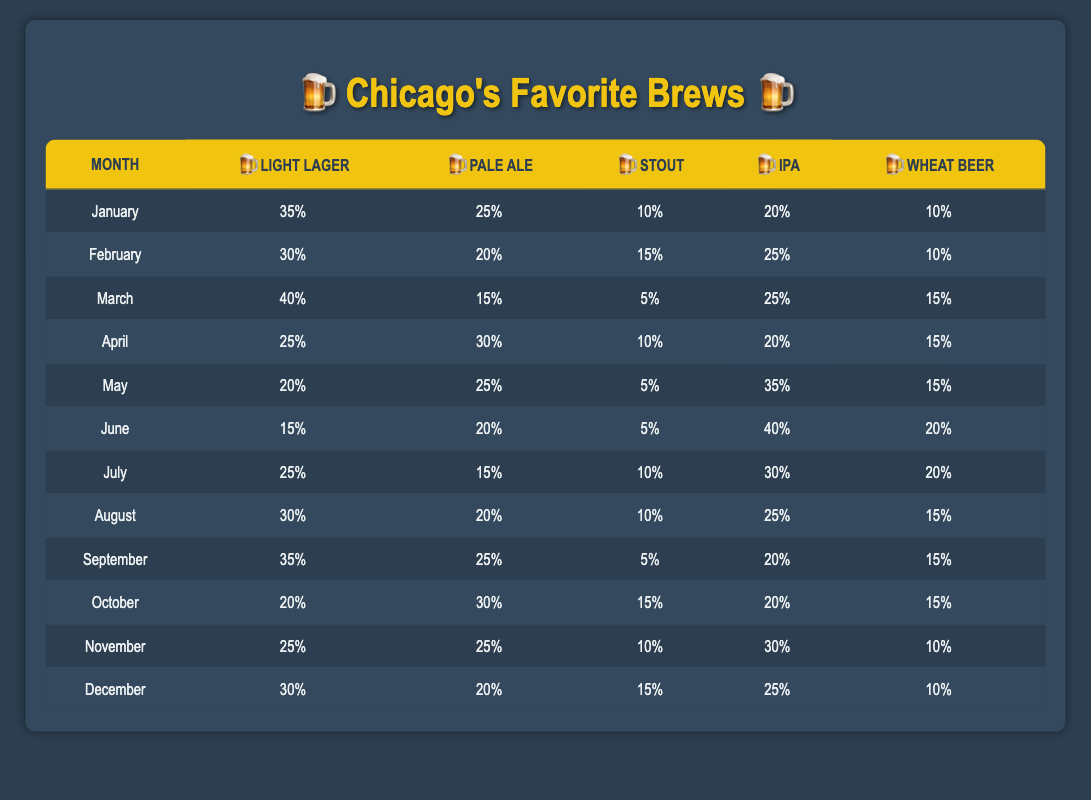What was the customer preference for Light Lager in December? In December, the percentage of customers who preferred Light Lager is listed in the table as 30%.
Answer: 30% Which beer type had the lowest percentage in March? In March, the Stout had the lowest percentage at 5%, compared to other types, which were higher.
Answer: 5% In which month did IPA reach its highest percentage and what was that percentage? Looking through the table, IPA reached its highest percentage in June at 40%.
Answer: 40% in June What is the total percentage preference for Pale Ale over the entire year? Summing the percentages for Pale Ale across all months: 25 + 20 + 15 + 30 + 25 + 20 + 15 + 20 + 25 + 30 + 25 + 20 = 300. The total percentage is 300%.
Answer: 300% Did customer preferences for Stout ever exceed 15%? By reviewing the table, Stout exceeded 15% in January (10%) and February (15%), but never went above that threshold in any month.
Answer: No What was the average percentage for Wheat Beer throughout the year? Wheat Beer percentages: 10, 10, 15, 15, 15, 20, 20, 15, 15, 15, 10, 10. The sum is 10 + 10 + 15 + 15 + 15 + 20 + 20 + 15 + 15 + 15 + 10 + 10 =  160. There are 12 values, so 160/12 = 13.33, rounded to two decimal points. The average is approximately 13.33%.
Answer: Approximately 13.33% What was the trend for Light Lager preference from January to June? Looking at the table, Light Lager preferences for January through June are: 35, 30, 40, 25, 20, and 15. The trend shows a fluctuation, first increasing from January to March, then decreasing steadily to June.
Answer: Fluctuation with a decrease 